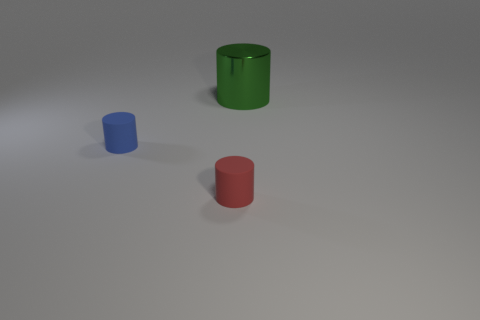Add 3 rubber cylinders. How many objects exist? 6 Subtract all small matte cylinders. How many cylinders are left? 1 Subtract 1 cylinders. How many cylinders are left? 2 Subtract all small cylinders. Subtract all large green metal objects. How many objects are left? 0 Add 3 big green things. How many big green things are left? 4 Add 3 big metallic things. How many big metallic things exist? 4 Subtract 0 blue spheres. How many objects are left? 3 Subtract all cyan cylinders. Subtract all cyan spheres. How many cylinders are left? 3 